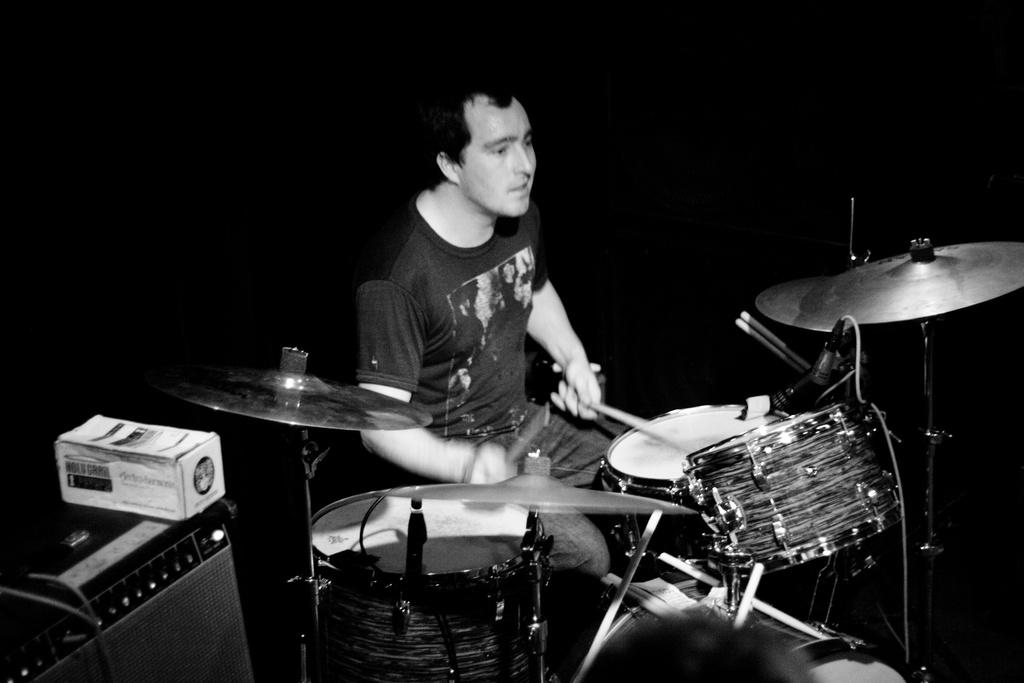What is the color scheme of the image? The image is black and white. What is the main subject of the image? There is a person playing drums in the center of the image. What can be seen on the left side of the image? There is a speaker and a box on the left side of the image. How would you describe the background of the image? The background of the image is dark. Can you tell me which tooth the person is using to play the drums in the image? There is no tooth involved in playing the drums in the image; the person is using drumsticks. 